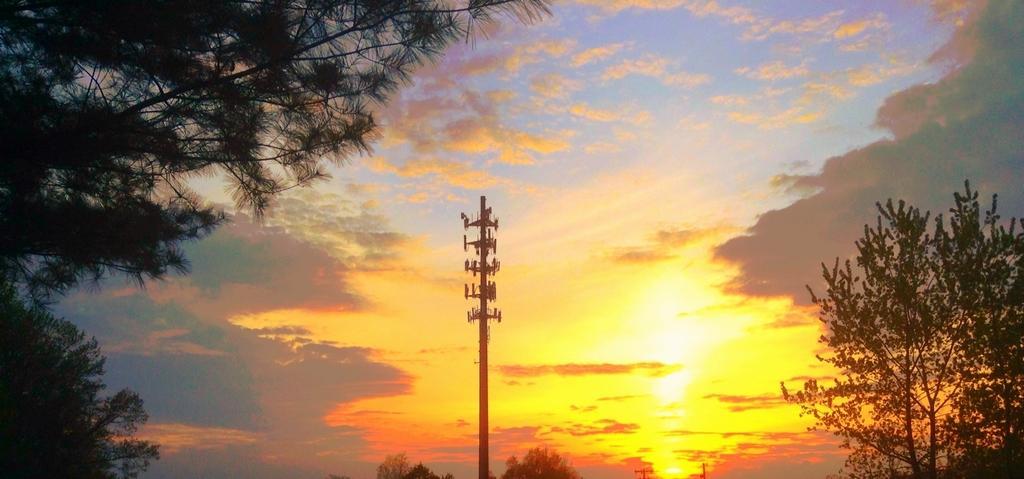Could you give a brief overview of what you see in this image? In this image there is a pole, on left side and right side there are trees, in the background there is the sky. 